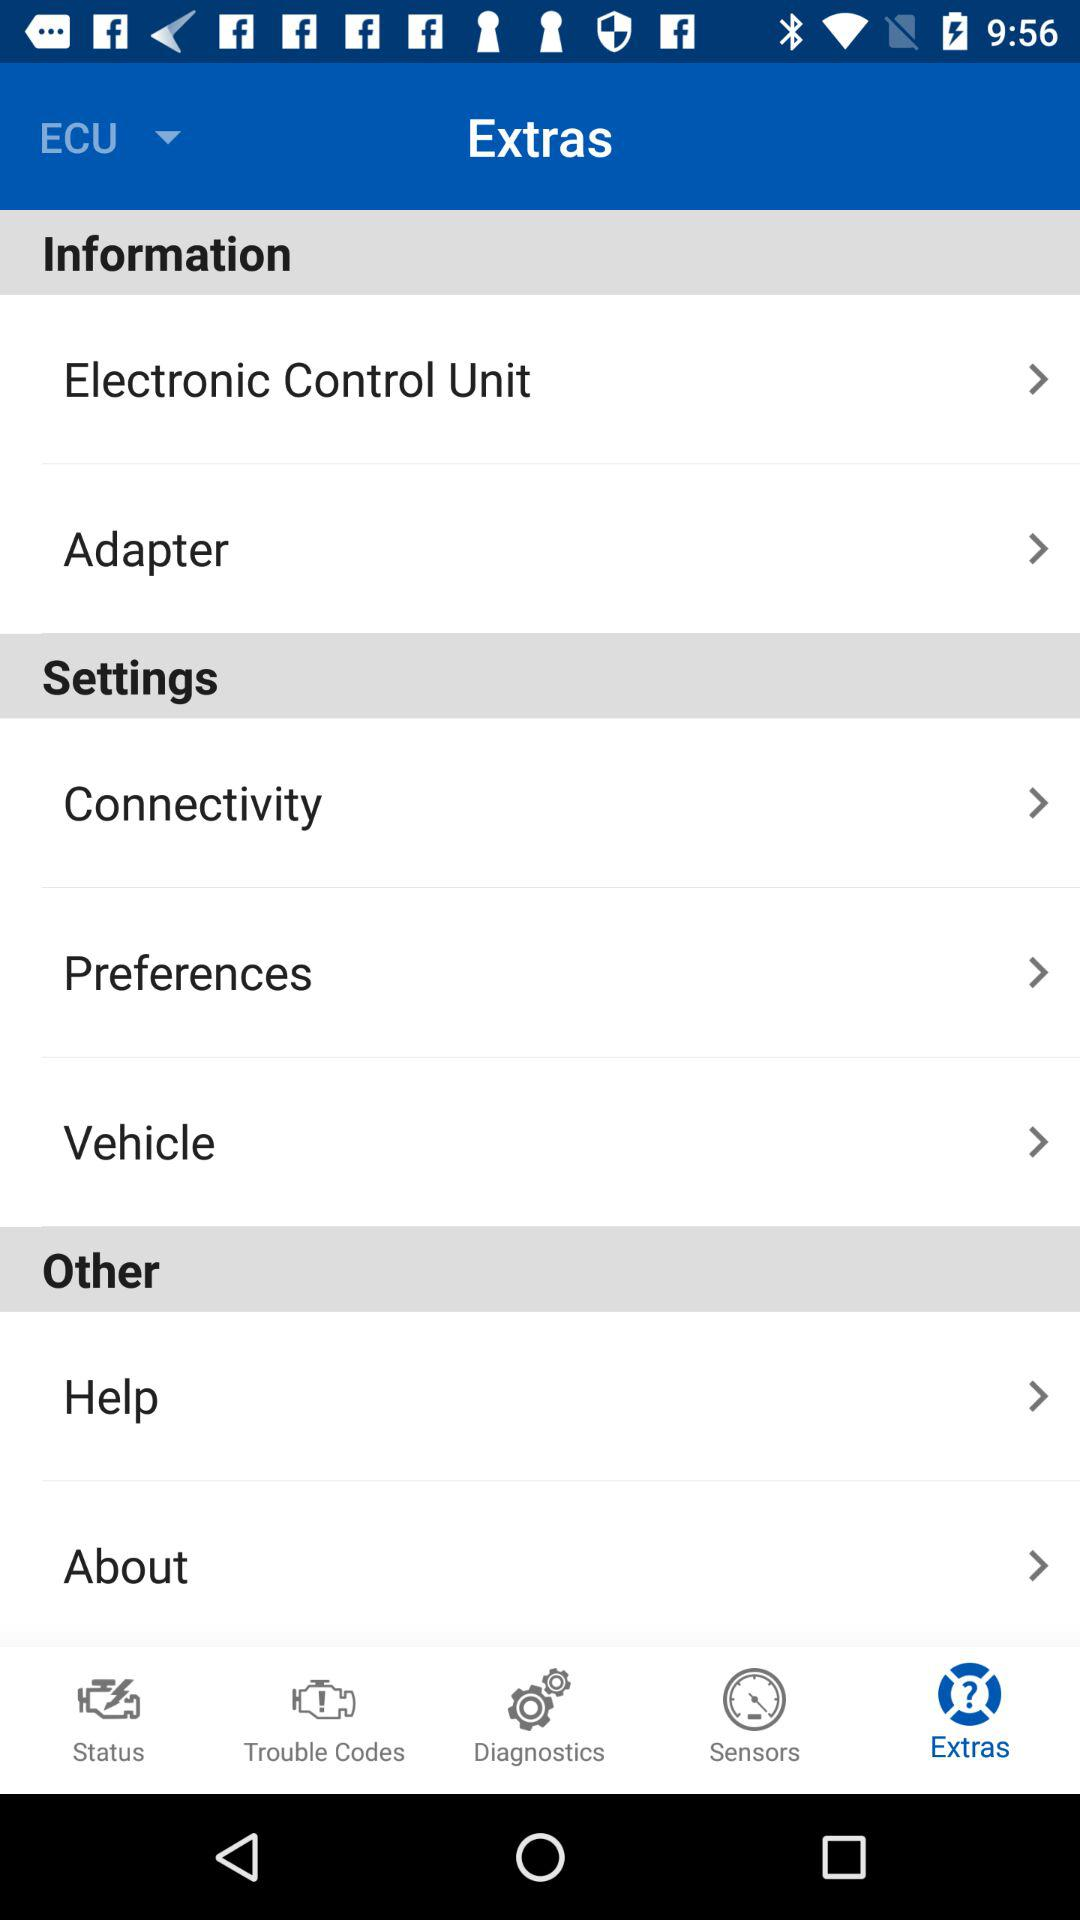Who do we contact for help?
When the provided information is insufficient, respond with <no answer>. <no answer> 